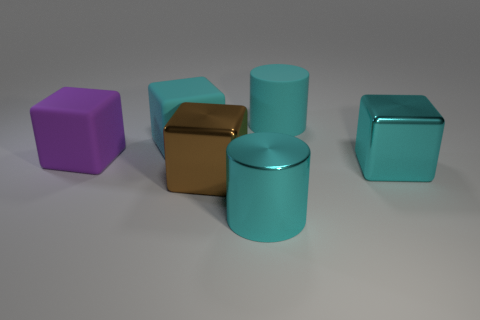Add 2 big cyan rubber objects. How many objects exist? 8 Subtract all cyan matte cubes. How many cubes are left? 3 Subtract all cyan blocks. How many blocks are left? 2 Subtract all cylinders. How many objects are left? 4 Subtract all cyan cylinders. How many purple cubes are left? 1 Add 5 cyan things. How many cyan things are left? 9 Add 4 big rubber things. How many big rubber things exist? 7 Subtract 0 green cylinders. How many objects are left? 6 Subtract 2 cubes. How many cubes are left? 2 Subtract all cyan cubes. Subtract all purple spheres. How many cubes are left? 2 